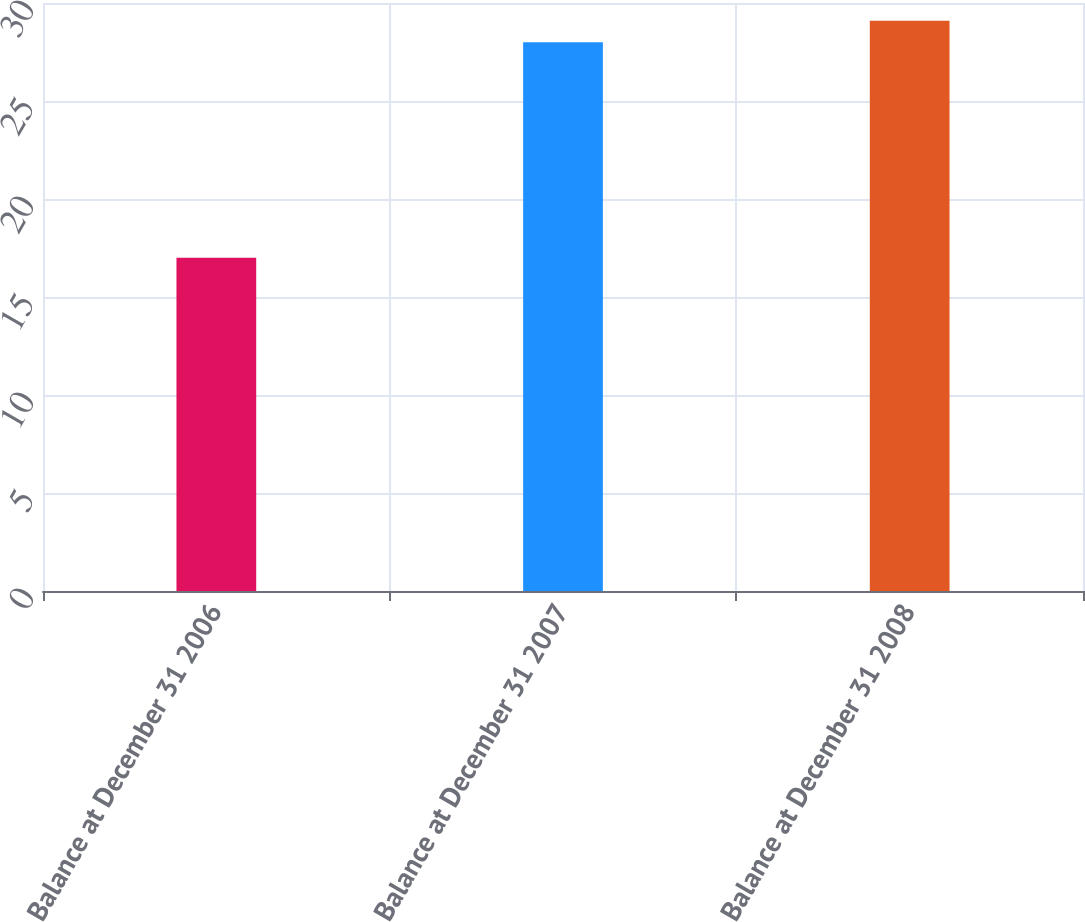<chart> <loc_0><loc_0><loc_500><loc_500><bar_chart><fcel>Balance at December 31 2006<fcel>Balance at December 31 2007<fcel>Balance at December 31 2008<nl><fcel>17<fcel>28<fcel>29.1<nl></chart> 